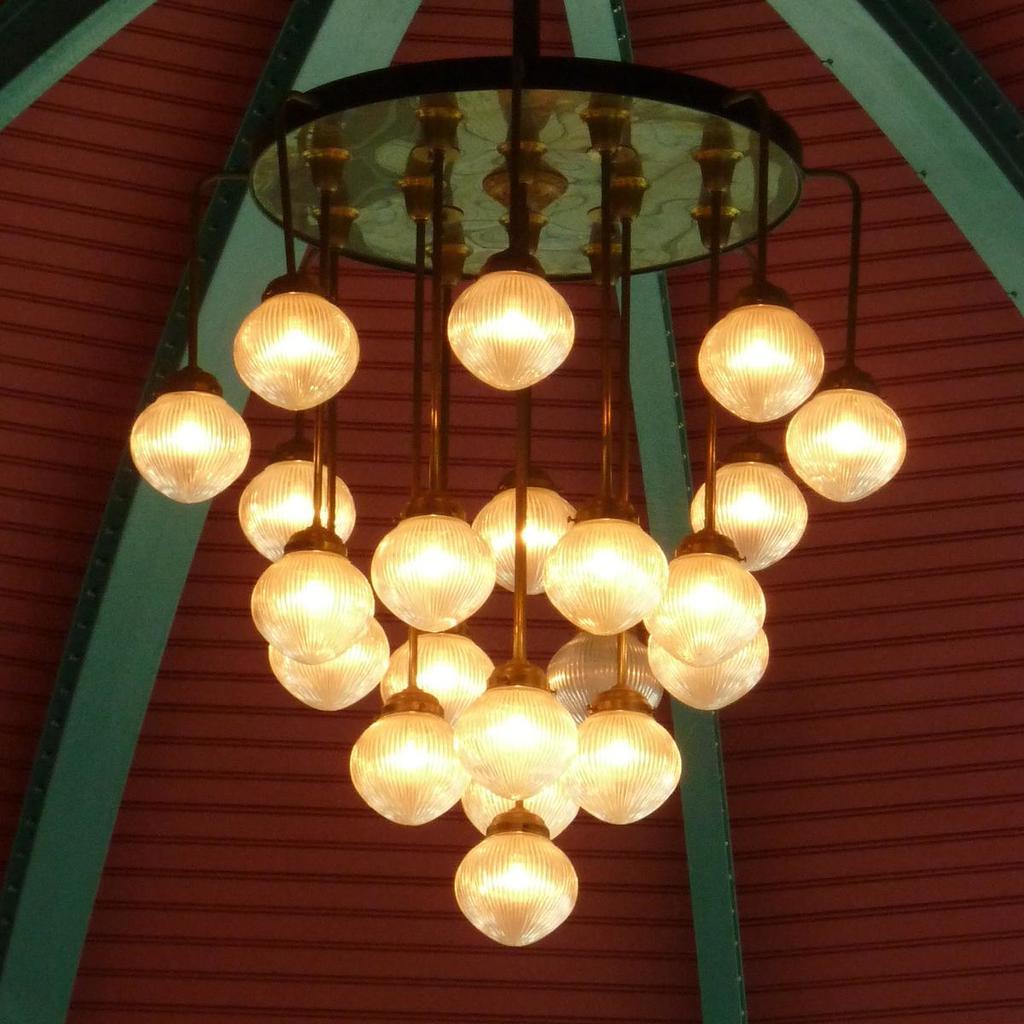Describe this image in one or two sentences. In this picture I can see there are lights attached to the ceiling and In the backdrop I can see there is a maroon ceiling and a green frame. 